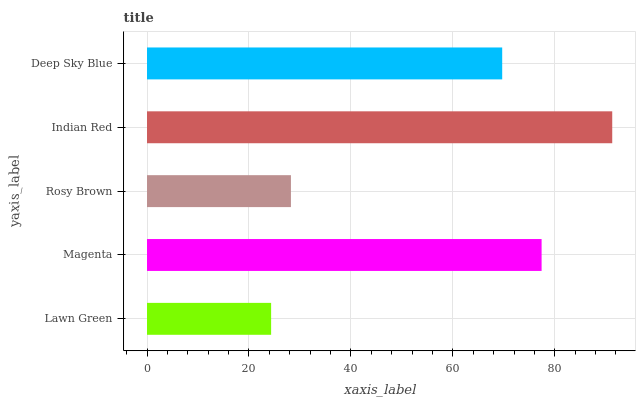Is Lawn Green the minimum?
Answer yes or no. Yes. Is Indian Red the maximum?
Answer yes or no. Yes. Is Magenta the minimum?
Answer yes or no. No. Is Magenta the maximum?
Answer yes or no. No. Is Magenta greater than Lawn Green?
Answer yes or no. Yes. Is Lawn Green less than Magenta?
Answer yes or no. Yes. Is Lawn Green greater than Magenta?
Answer yes or no. No. Is Magenta less than Lawn Green?
Answer yes or no. No. Is Deep Sky Blue the high median?
Answer yes or no. Yes. Is Deep Sky Blue the low median?
Answer yes or no. Yes. Is Indian Red the high median?
Answer yes or no. No. Is Rosy Brown the low median?
Answer yes or no. No. 